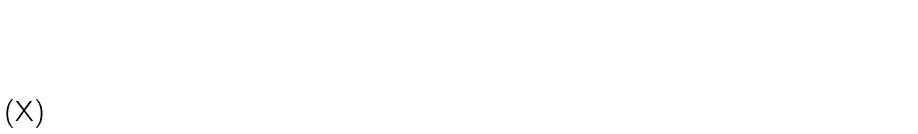Convert formula to latex. <formula><loc_0><loc_0><loc_500><loc_500>\begin{smallmatrix} 2 & 1 & 1 & 1 & 0 & 0 & 0 \\ 1 & 3 & 1 & 1 & 1 & 1 & 1 \\ 1 & 1 & 3 & 1 & 1 & 0 & 0 \\ 1 & 1 & 1 & 3 & 1 & 0 & 0 \\ 0 & 1 & 1 & 1 & 3 & 1 & 0 \\ 0 & 1 & 0 & 0 & 1 & 3 & 1 \\ 0 & 1 & 0 & 0 & 0 & 1 & 3 \end{smallmatrix}</formula> 